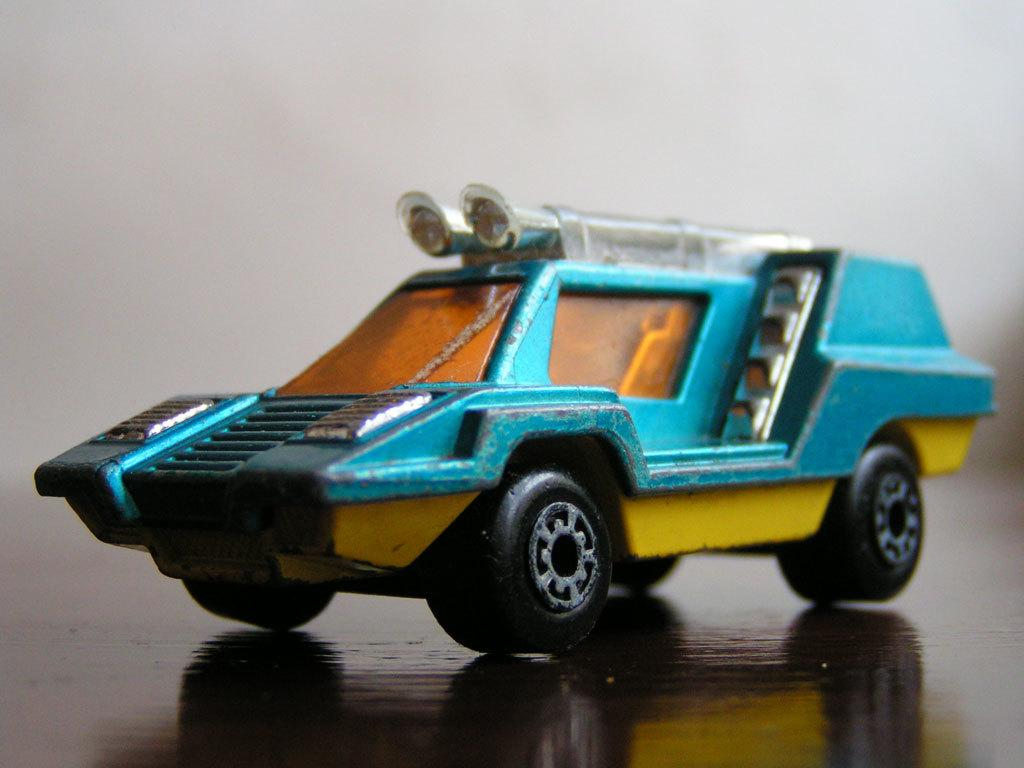What is the main object in the image? There is a toy car in the image. On what surface is the toy car placed? The toy car is placed on a wooden surface. Can you describe the background of the image? The backdrop of the image is blurred. What type of pear is placed on the tray in the image? There is no pear or tray present in the image; it features a toy car placed on a wooden surface with a blurred backdrop. 